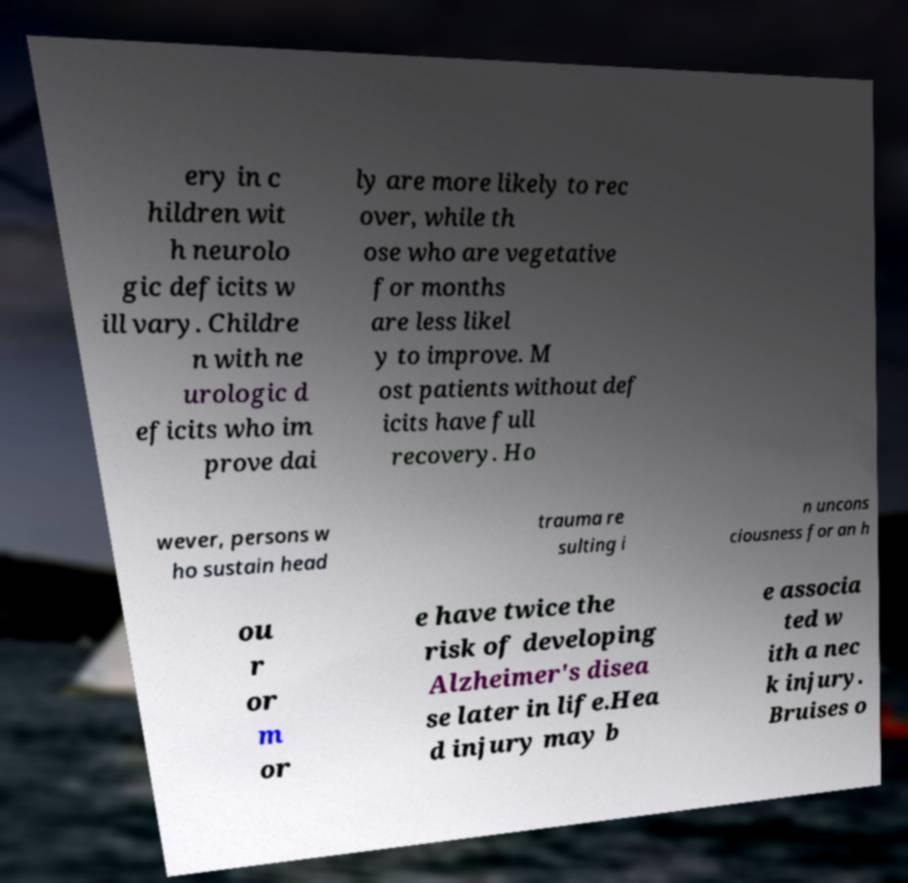I need the written content from this picture converted into text. Can you do that? ery in c hildren wit h neurolo gic deficits w ill vary. Childre n with ne urologic d eficits who im prove dai ly are more likely to rec over, while th ose who are vegetative for months are less likel y to improve. M ost patients without def icits have full recovery. Ho wever, persons w ho sustain head trauma re sulting i n uncons ciousness for an h ou r or m or e have twice the risk of developing Alzheimer's disea se later in life.Hea d injury may b e associa ted w ith a nec k injury. Bruises o 